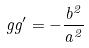Convert formula to latex. <formula><loc_0><loc_0><loc_500><loc_500>g g ^ { \prime } = - \frac { b ^ { 2 } } { a ^ { 2 } }</formula> 